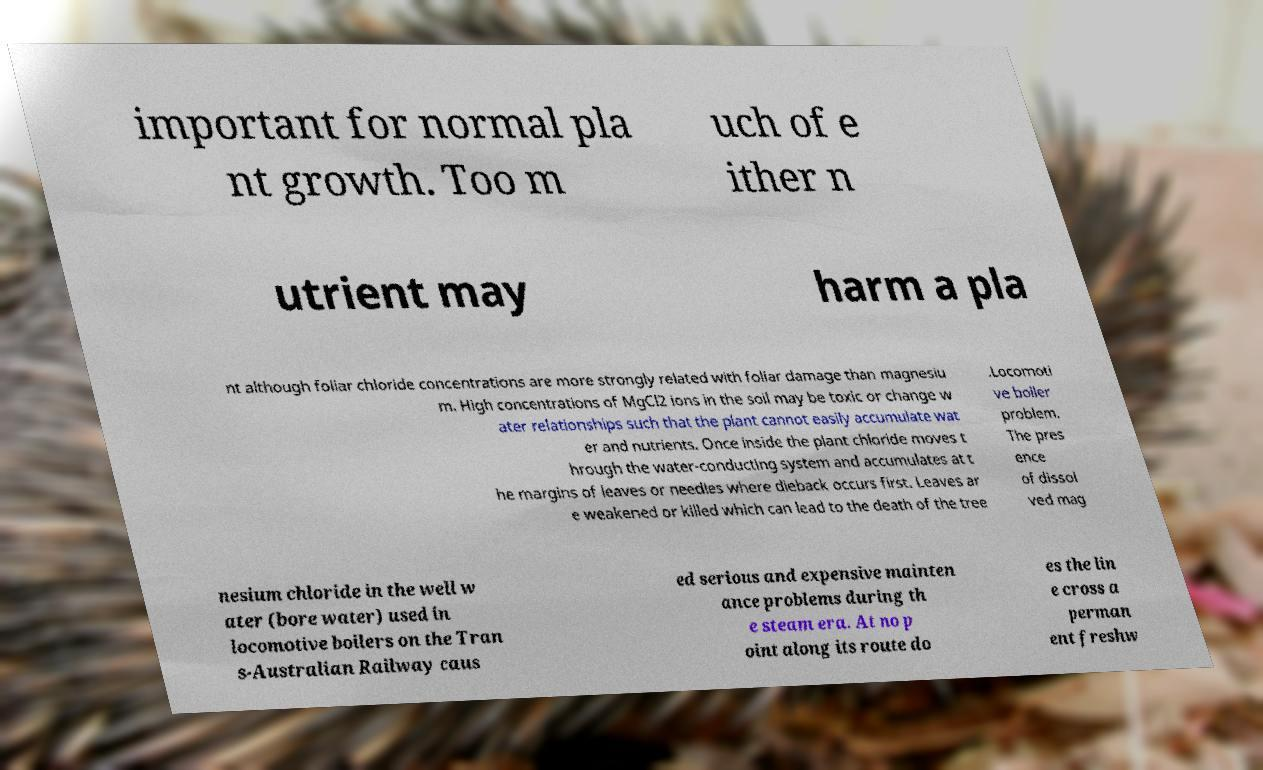Please read and relay the text visible in this image. What does it say? important for normal pla nt growth. Too m uch of e ither n utrient may harm a pla nt although foliar chloride concentrations are more strongly related with foliar damage than magnesiu m. High concentrations of MgCl2 ions in the soil may be toxic or change w ater relationships such that the plant cannot easily accumulate wat er and nutrients. Once inside the plant chloride moves t hrough the water-conducting system and accumulates at t he margins of leaves or needles where dieback occurs first. Leaves ar e weakened or killed which can lead to the death of the tree .Locomoti ve boiler problem. The pres ence of dissol ved mag nesium chloride in the well w ater (bore water) used in locomotive boilers on the Tran s-Australian Railway caus ed serious and expensive mainten ance problems during th e steam era. At no p oint along its route do es the lin e cross a perman ent freshw 